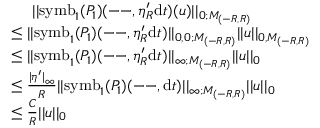Convert formula to latex. <formula><loc_0><loc_0><loc_500><loc_500>\begin{array} { r l } & { \quad \ | | s y m b _ { 1 } ( P _ { 1 } ) ( - - , \eta _ { R } ^ { \prime } d t ) ( u ) | | _ { 0 ; M _ { ( - R , R ) } } } \\ & { \leq | | s y m b _ { 1 } ( P _ { 1 } ) ( - - , \eta _ { R } ^ { \prime } d t ) | | _ { 0 , 0 ; M _ { ( - R , R ) } } | | u | | _ { 0 , M _ { ( - R , R ) } } } \\ & { \leq | | s y m b _ { 1 } ( P _ { 1 } ) ( - - , \eta _ { R } ^ { \prime } d t ) | | _ { \infty ; M _ { ( - R , R ) } } | | u | | _ { 0 } } \\ & { \leq \frac { | \eta ^ { \prime } | _ { \infty } } { R } | | s y m b _ { 1 } ( P _ { 1 } ) ( - - , d t ) | | _ { \infty ; M _ { ( - R , R ) } } | | u | | _ { 0 } } \\ & { \leq \frac { C } { R } | | u | | _ { 0 } } \end{array}</formula> 